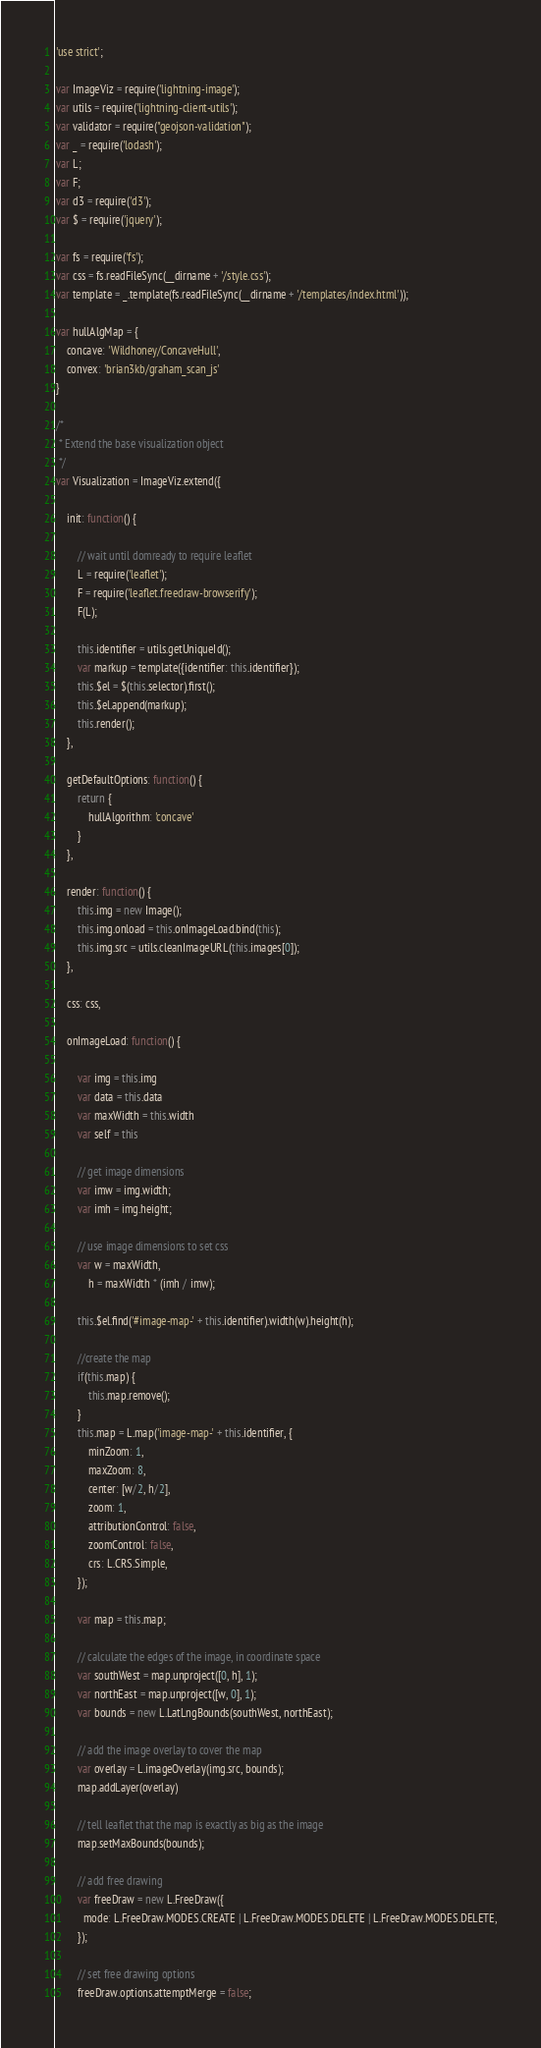<code> <loc_0><loc_0><loc_500><loc_500><_JavaScript_>'use strict';

var ImageViz = require('lightning-image');
var utils = require('lightning-client-utils');
var validator = require("geojson-validation");
var _ = require('lodash');
var L;
var F;
var d3 = require('d3');
var $ = require('jquery');

var fs = require('fs');
var css = fs.readFileSync(__dirname + '/style.css');
var template = _.template(fs.readFileSync(__dirname + '/templates/index.html'));

var hullAlgMap = {
    concave: 'Wildhoney/ConcaveHull',
    convex: 'brian3kb/graham_scan_js'
}

/*
 * Extend the base visualization object
 */
var Visualization = ImageViz.extend({

    init: function() {

        // wait until domready to require leaflet
        L = require('leaflet');
        F = require('leaflet.freedraw-browserify');
        F(L);

        this.identifier = utils.getUniqueId();
        var markup = template({identifier: this.identifier});
        this.$el = $(this.selector).first();
        this.$el.append(markup);
        this.render();
    },

    getDefaultOptions: function() {
        return {
            hullAlgorithm: 'concave'
        }
    },

    render: function() {
        this.img = new Image();
        this.img.onload = this.onImageLoad.bind(this);
        this.img.src = utils.cleanImageURL(this.images[0]);
    },

    css: css,

    onImageLoad: function() {

        var img = this.img
        var data = this.data
        var maxWidth = this.width
        var self = this

        // get image dimensions
        var imw = img.width;
        var imh = img.height;

        // use image dimensions to set css
        var w = maxWidth,
            h = maxWidth * (imh / imw);

        this.$el.find('#image-map-' + this.identifier).width(w).height(h);

        //create the map
        if(this.map) {
            this.map.remove();
        }
        this.map = L.map('image-map-' + this.identifier, {
            minZoom: 1,
            maxZoom: 8,
            center: [w/2, h/2],
            zoom: 1,
            attributionControl: false,
            zoomControl: false,
            crs: L.CRS.Simple,
        });

        var map = this.map;

        // calculate the edges of the image, in coordinate space
        var southWest = map.unproject([0, h], 1);
        var northEast = map.unproject([w, 0], 1);
        var bounds = new L.LatLngBounds(southWest, northEast);

        // add the image overlay to cover the map
        var overlay = L.imageOverlay(img.src, bounds);
        map.addLayer(overlay)

        // tell leaflet that the map is exactly as big as the image
        map.setMaxBounds(bounds);

        // add free drawing
        var freeDraw = new L.FreeDraw({
          mode: L.FreeDraw.MODES.CREATE | L.FreeDraw.MODES.DELETE | L.FreeDraw.MODES.DELETE,
        });

        // set free drawing options
        freeDraw.options.attemptMerge = false;</code> 